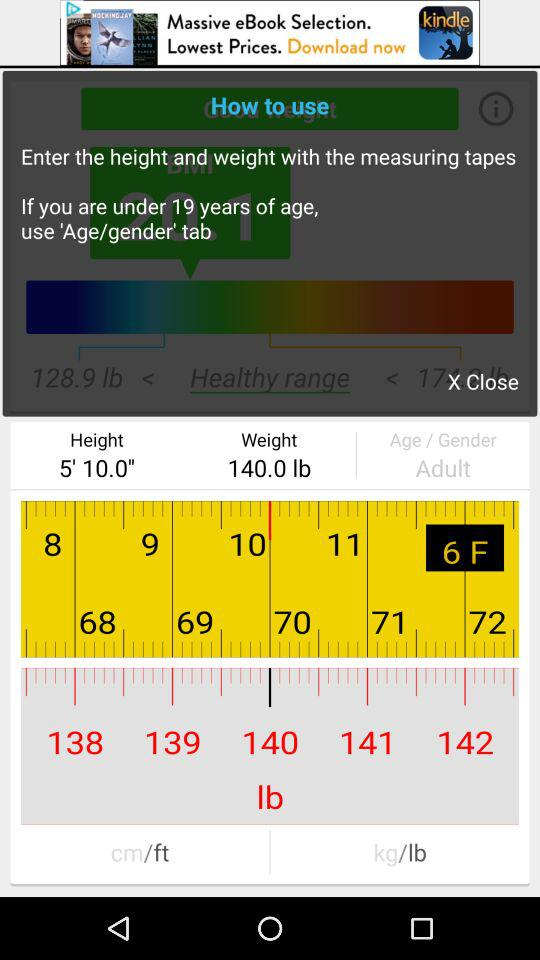What is the value of the age/gender text field?
Answer the question using a single word or phrase. Adult 